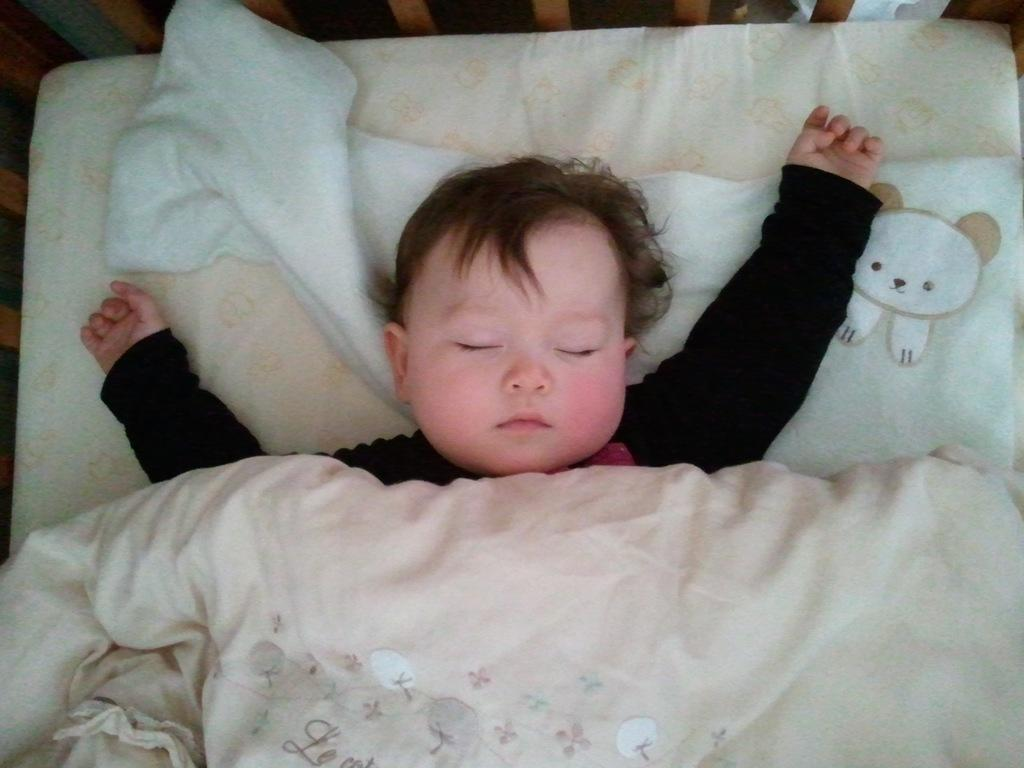What is the main subject of the picture? The main subject of the picture is an infant. What is the infant doing in the picture? The infant is sleeping. What is the infant wearing in the picture? The infant is wearing a black shirt. Is there anything covering the infant in the picture? Yes, there is a blanket on the baby. What type of trucks can be seen in the background of the picture? There are no trucks visible in the picture; it features an infant sleeping with a blanket. Is there a lock on the baby's crib in the picture? There is no crib present in the picture, so it is not possible to determine if there is a lock on it. 